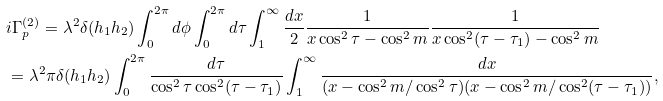<formula> <loc_0><loc_0><loc_500><loc_500>& i \Gamma _ { p } ^ { ( 2 ) } = \lambda ^ { 2 } \delta ( h _ { 1 } h _ { 2 } ) \int _ { 0 } ^ { 2 \pi } d \phi \int _ { 0 } ^ { 2 \pi } d \tau \int _ { 1 } ^ { \infty } \frac { d x } { 2 } \frac { 1 } { x \cos ^ { 2 } \tau - \cos ^ { 2 } m } \frac { 1 } { x \cos ^ { 2 } ( \tau - \tau _ { 1 } ) - \cos ^ { 2 } m } \\ & = \lambda ^ { 2 } \pi \delta ( h _ { 1 } h _ { 2 } ) \int _ { 0 } ^ { 2 \pi } \frac { d \tau } { \cos ^ { 2 } \tau \cos ^ { 2 } ( \tau - \tau _ { 1 } ) } \int _ { 1 } ^ { \infty } \frac { d x } { ( x - \cos ^ { 2 } m / \cos ^ { 2 } \tau ) ( x - \cos ^ { 2 } m / \cos ^ { 2 } ( \tau - \tau _ { 1 } ) ) } ,</formula> 